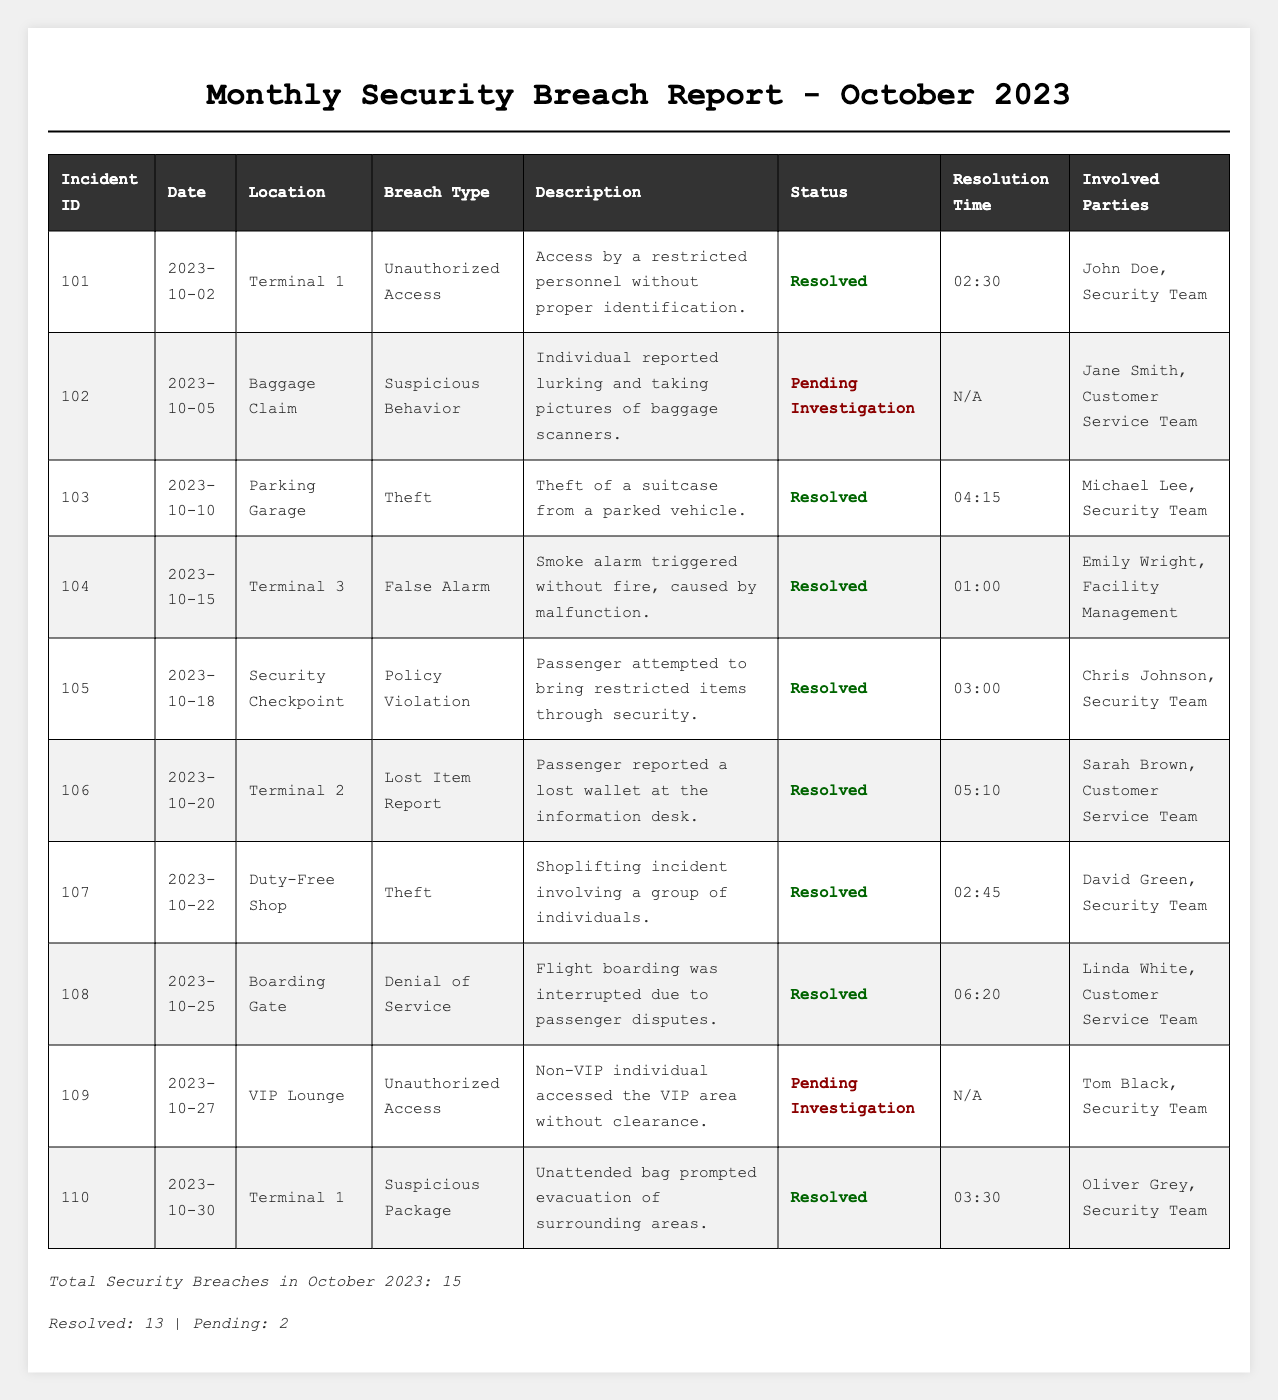What is the total number of security breaches reported in October 2023? The table indicates that the total number of security breaches is listed at the bottom, which states, "Total Security Breaches in October 2023: 15."
Answer: 15 How many of the incidents were resolved? The table summary states that there are 13 resolved incidents. This is explicitly mentioned in the phrase, "Resolved: 13."
Answer: 13 What is the status of incident ID 102? In the table, incident ID 102 has a status indicated as "Pending Investigation." This can be found directly in the row for incident ID 102.
Answer: Pending Investigation Which location had a theft incident reported? The table shows two incidents labeled as Theft: one at the "Parking Garage" (incident ID 103) and another at the "Duty-Free Shop" (incident ID 107). Both locations can be identified in their respective rows.
Answer: Parking Garage and Duty-Free Shop How many incidents were classified as "Unauthorized Access"? The table lists two "Unauthorized Access" incidents: one on October 2 (incident ID 101) and another on October 27 (incident ID 109). By counting these rows, the total is found to be 2.
Answer: 2 What was the resolution time for incident ID 106? The resolution time for incident ID 106 (Lost Item Report) is stated in the respective table row as "05:10." This is a direct extraction from the table.
Answer: 05:10 Is there any incident that occurred at the Boarding Gate? The table lists an incident at the Boarding Gate with incident ID 108, which is categorized as "Denial of Service." This information is readily visible in the table.
Answer: Yes Which breach type was reported at Terminal 3? The breach type reported at Terminal 3 is "False Alarm," as indicated in the respective row (incident ID 104). This can be observed directly in the table.
Answer: False Alarm What percentage of the total breaches are pending resolution? There are 2 pending incidents out of a total of 15 breaches. To calculate the percentage: (2 / 15) * 100 = 13.33%. This follows from the total and the pending numbers provided in the summary.
Answer: 13.33% Which day had the highest number of resolved incidents? To determine the day with the highest number of resolved incidents, note that multiple resolved incidents occurred throughout the month, however, no specific day is indicated to have more than one; each resolved incident is unique to a day. This suggests that no single day had more than one resolved case.
Answer: No specific day had the highest; each resolved was unique What can be inferred about the response times for resolved incidents? The resolution times for resolved incidents range from 01:00 to 06:20. While exact averages cannot be calculated from the summary alone, it can be inferred that response times varied, with no clear average provided; individuals involved may have responded at different times based on the nature of each incident.
Answer: Response times varied, no average calculated 